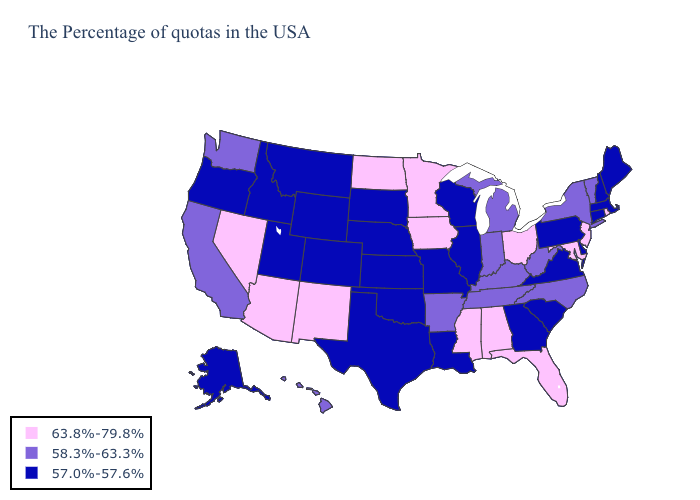What is the value of Mississippi?
Answer briefly. 63.8%-79.8%. Name the states that have a value in the range 57.0%-57.6%?
Write a very short answer. Maine, Massachusetts, New Hampshire, Connecticut, Delaware, Pennsylvania, Virginia, South Carolina, Georgia, Wisconsin, Illinois, Louisiana, Missouri, Kansas, Nebraska, Oklahoma, Texas, South Dakota, Wyoming, Colorado, Utah, Montana, Idaho, Oregon, Alaska. Does Mississippi have the highest value in the USA?
Answer briefly. Yes. Does Washington have the highest value in the USA?
Answer briefly. No. What is the value of Connecticut?
Be succinct. 57.0%-57.6%. Name the states that have a value in the range 58.3%-63.3%?
Short answer required. Vermont, New York, North Carolina, West Virginia, Michigan, Kentucky, Indiana, Tennessee, Arkansas, California, Washington, Hawaii. What is the value of Georgia?
Quick response, please. 57.0%-57.6%. Among the states that border Texas , does New Mexico have the highest value?
Be succinct. Yes. What is the lowest value in the USA?
Answer briefly. 57.0%-57.6%. Does North Dakota have the highest value in the MidWest?
Give a very brief answer. Yes. Does Wyoming have the lowest value in the USA?
Concise answer only. Yes. Does Iowa have the highest value in the USA?
Concise answer only. Yes. Is the legend a continuous bar?
Give a very brief answer. No. Name the states that have a value in the range 63.8%-79.8%?
Short answer required. Rhode Island, New Jersey, Maryland, Ohio, Florida, Alabama, Mississippi, Minnesota, Iowa, North Dakota, New Mexico, Arizona, Nevada. Which states have the lowest value in the MidWest?
Quick response, please. Wisconsin, Illinois, Missouri, Kansas, Nebraska, South Dakota. 